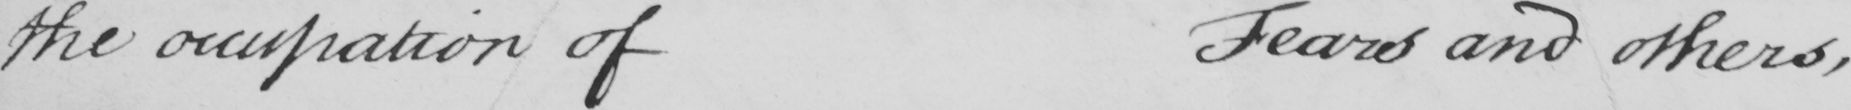Can you tell me what this handwritten text says? the occupation of Fears and others , 